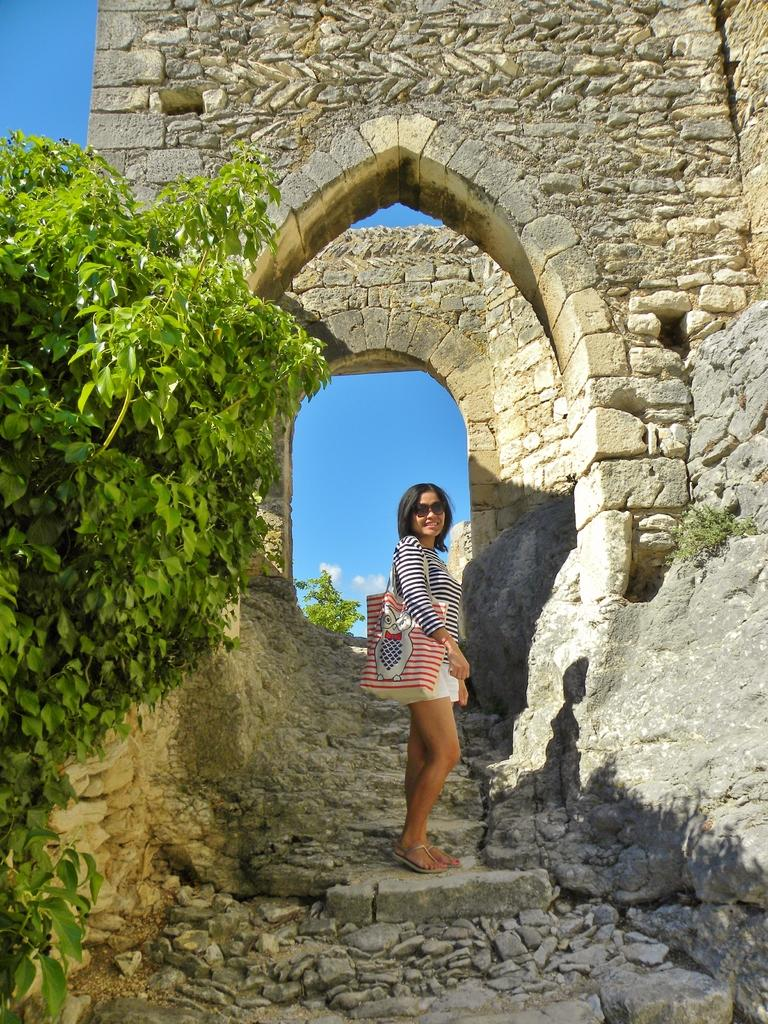Who is present in the image? There is a person in the image. What is the person doing in the image? The person is smiling in the image. Where is the person located in the image? The person is standing on a staircase in the image. What can be seen in the background of the image? There are arches of a building, plants, and the sky visible in the background of the image. What type of vein is visible on the person's forehead in the image? There is no visible vein on the person's forehead in the image. What type of suit is the person wearing in the image? The person is not wearing a suit in the image. 